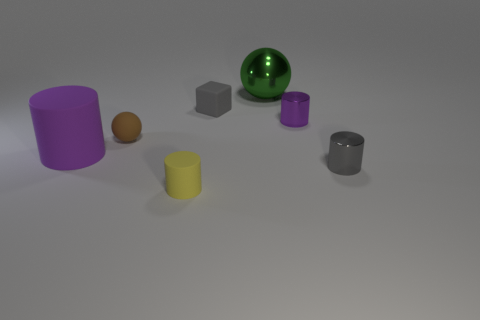Does the small metallic cylinder behind the purple matte cylinder have the same color as the large object in front of the large green metal thing?
Your answer should be compact. Yes. There is a gray matte block; are there any yellow cylinders in front of it?
Provide a succinct answer. Yes. How many big green shiny things have the same shape as the brown object?
Offer a terse response. 1. What color is the sphere to the left of the matte cylinder in front of the small gray object that is to the right of the big ball?
Your answer should be very brief. Brown. Do the small cylinder behind the purple matte object and the small gray thing that is right of the big sphere have the same material?
Offer a terse response. Yes. What number of objects are purple cylinders on the left side of the small rubber sphere or tiny metallic cylinders?
Ensure brevity in your answer.  3. How many objects are either tiny blue metal objects or gray things that are behind the small gray metal cylinder?
Your response must be concise. 1. What number of yellow shiny cubes have the same size as the gray metallic cylinder?
Give a very brief answer. 0. Is the number of tiny yellow matte cylinders behind the yellow cylinder less than the number of tiny metal cylinders in front of the small purple metallic thing?
Make the answer very short. Yes. How many rubber objects are gray spheres or tiny brown objects?
Offer a very short reply. 1. 